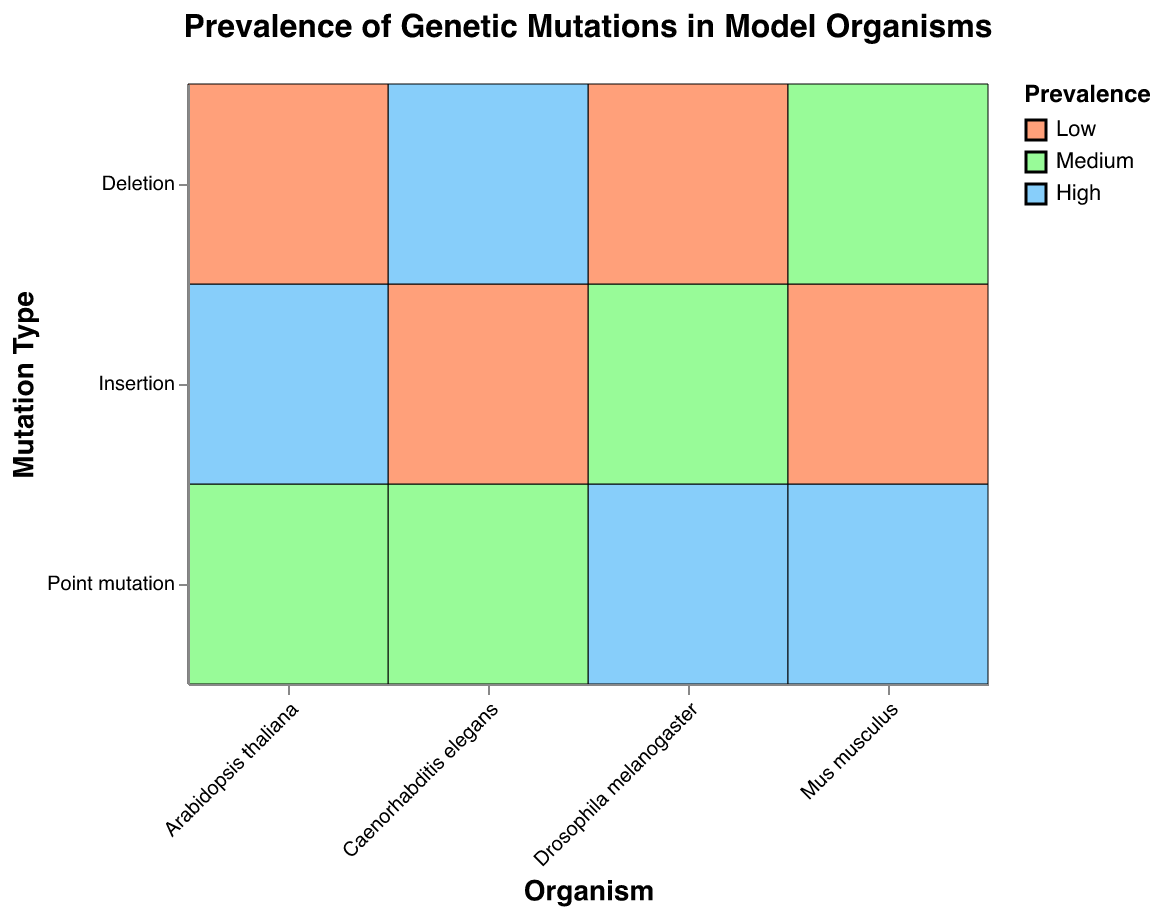Which organism has the highest prevalence of point mutations? By examining the color associated with "High" prevalence in the color legend, we can see that Drosophila melanogaster and Mus musculus have the highest prevalence for point mutations, as indicated by the blue color.
Answer: Drosophila melanogaster and Mus musculus Which organism has the lowest prevalence of insertion mutations? Referring to the color representing "Low" prevalence in the legend, we observe that Caenorhabditis elegans and Mus musculus are associated with the color representing "Low" in the "Insertion" column.
Answer: Caenorhabditis elegans and Mus musculus Which mutation type has a medium prevalence in Arabidopsis thaliana? By looking at the "Arabidopsis thaliana" column and identifying the color for "Medium" prevalence in the legend, we find that "Point mutation" is medium in Arabidopsis thaliana.
Answer: Point mutation How many model organisms have deletion mutations with low prevalence? We check the "Deletion" row for any instances of the color representing "Low" prevalence. Both Drosophila melanogaster and Arabidopsis thaliana show low prevalence for deletion mutations.
Answer: 2 Which organism and mutation type combination has a medium prevalence in Caenorhabditis elegans? Observing the "Caenorhabditis elegans" column and finding the color for "Medium" prevalence, we see that "Point mutation" has a medium prevalence.
Answer: Point mutation Compare the prevalence of insertion mutations between Mus musculus and Arabidopsis thaliana. By looking at the "Insertion" row for both Mus musculus and Arabidopsis thaliana, we see that Mus musculus has a "Low" prevalence (lighter color) while Arabidopsis thaliana has a "High" prevalence (darker color).
Answer: Arabidopsis thaliana has higher prevalence What is the most prevalent mutation type in Drosophila melanogaster? In the "Drosophila melanogaster" column, the color representing "High" prevalence indicates that "Point mutation" is the most prevalent type.
Answer: Point mutation Which organism has a high prevalence of deletion mutations? The "Deletion" row shows that Caenorhabditis elegans is associated with the color representing "High" prevalence.
Answer: Caenorhabditis elegans 